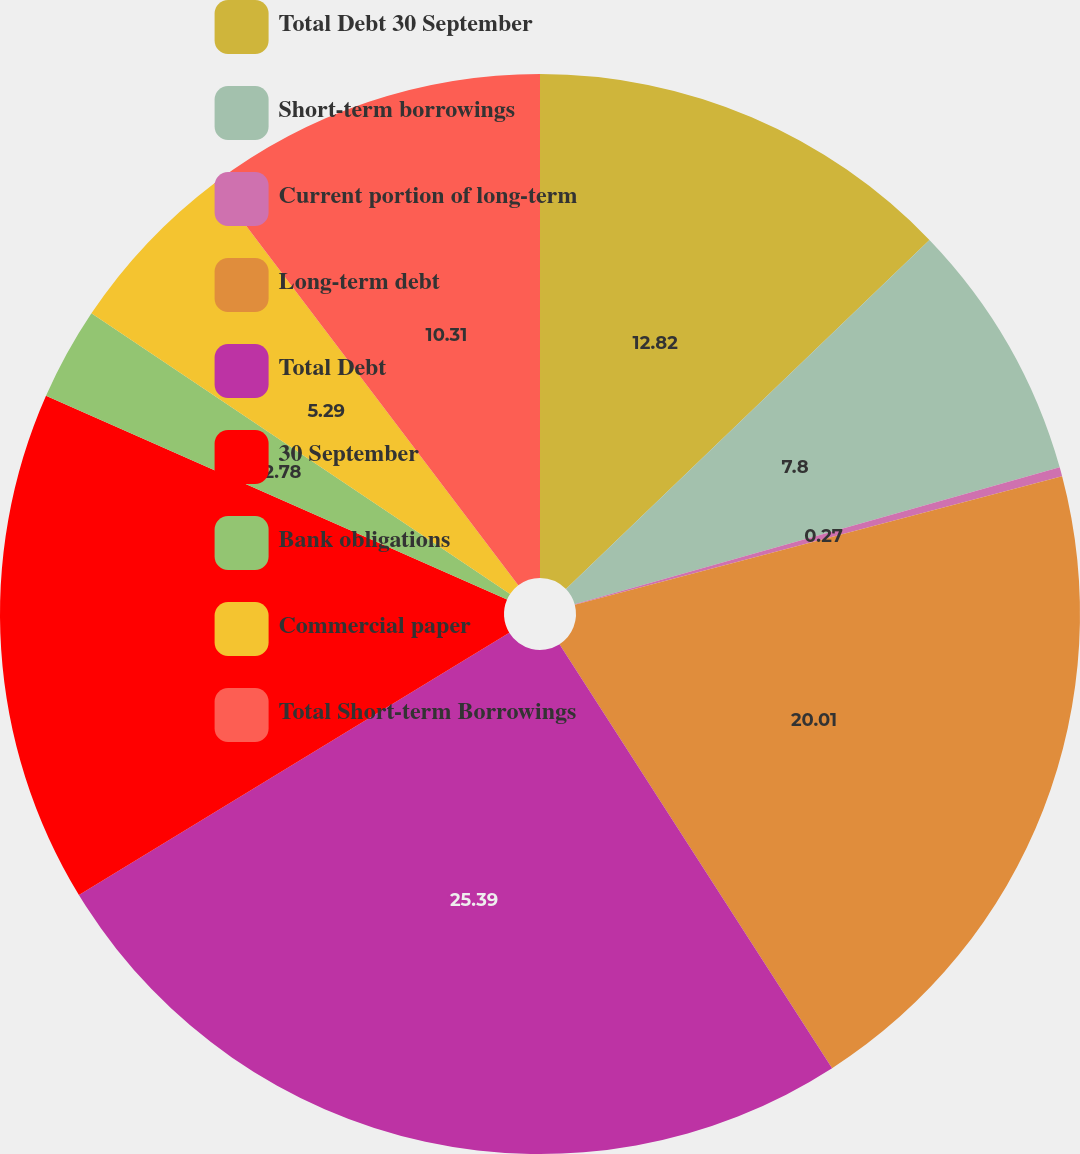<chart> <loc_0><loc_0><loc_500><loc_500><pie_chart><fcel>Total Debt 30 September<fcel>Short-term borrowings<fcel>Current portion of long-term<fcel>Long-term debt<fcel>Total Debt<fcel>30 September<fcel>Bank obligations<fcel>Commercial paper<fcel>Total Short-term Borrowings<nl><fcel>12.82%<fcel>7.8%<fcel>0.27%<fcel>20.01%<fcel>25.38%<fcel>15.33%<fcel>2.78%<fcel>5.29%<fcel>10.31%<nl></chart> 